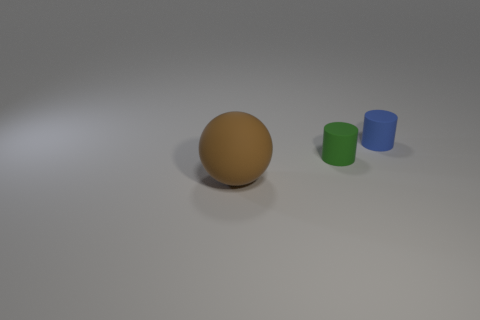Add 1 large brown matte spheres. How many objects exist? 4 Subtract all cylinders. How many objects are left? 1 Add 2 brown things. How many brown things are left? 3 Add 2 large brown rubber objects. How many large brown rubber objects exist? 3 Subtract 0 brown blocks. How many objects are left? 3 Subtract all brown rubber balls. Subtract all balls. How many objects are left? 1 